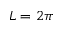<formula> <loc_0><loc_0><loc_500><loc_500>L = 2 \pi</formula> 